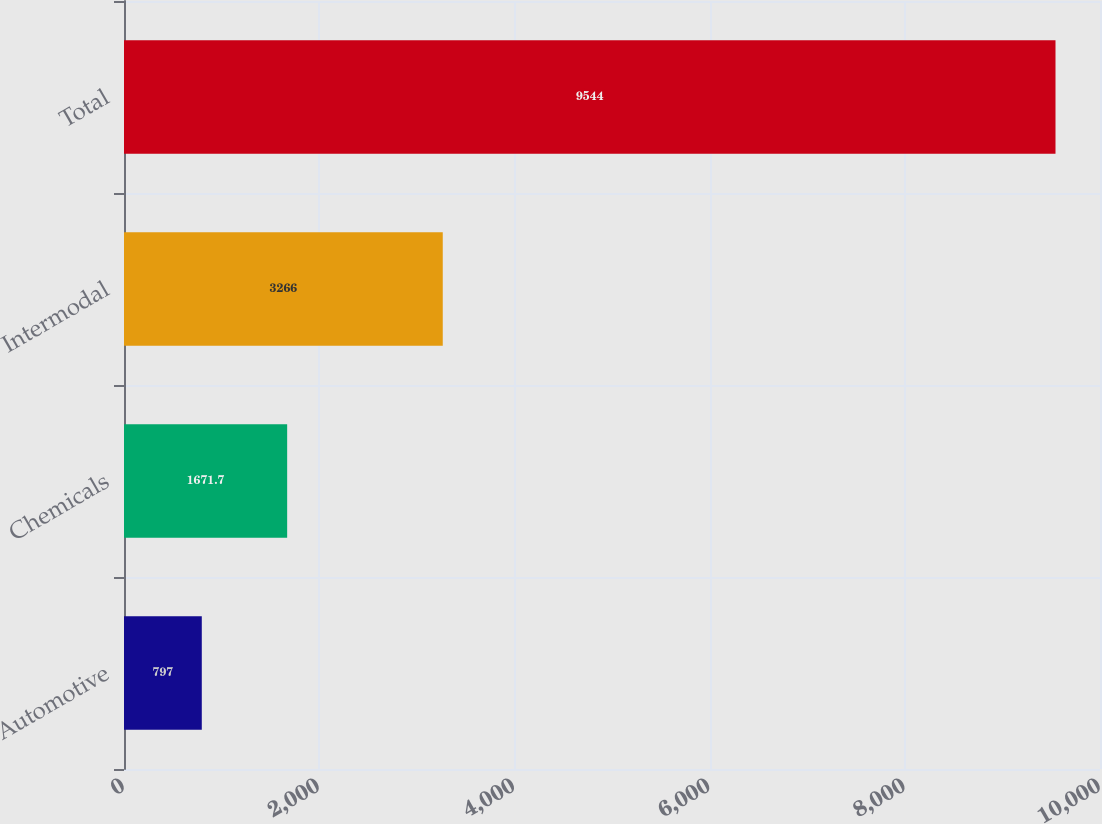Convert chart to OTSL. <chart><loc_0><loc_0><loc_500><loc_500><bar_chart><fcel>Automotive<fcel>Chemicals<fcel>Intermodal<fcel>Total<nl><fcel>797<fcel>1671.7<fcel>3266<fcel>9544<nl></chart> 